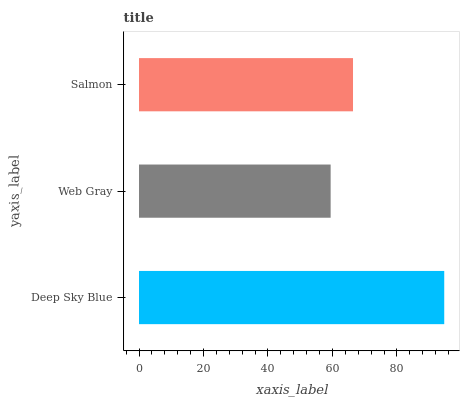Is Web Gray the minimum?
Answer yes or no. Yes. Is Deep Sky Blue the maximum?
Answer yes or no. Yes. Is Salmon the minimum?
Answer yes or no. No. Is Salmon the maximum?
Answer yes or no. No. Is Salmon greater than Web Gray?
Answer yes or no. Yes. Is Web Gray less than Salmon?
Answer yes or no. Yes. Is Web Gray greater than Salmon?
Answer yes or no. No. Is Salmon less than Web Gray?
Answer yes or no. No. Is Salmon the high median?
Answer yes or no. Yes. Is Salmon the low median?
Answer yes or no. Yes. Is Deep Sky Blue the high median?
Answer yes or no. No. Is Web Gray the low median?
Answer yes or no. No. 